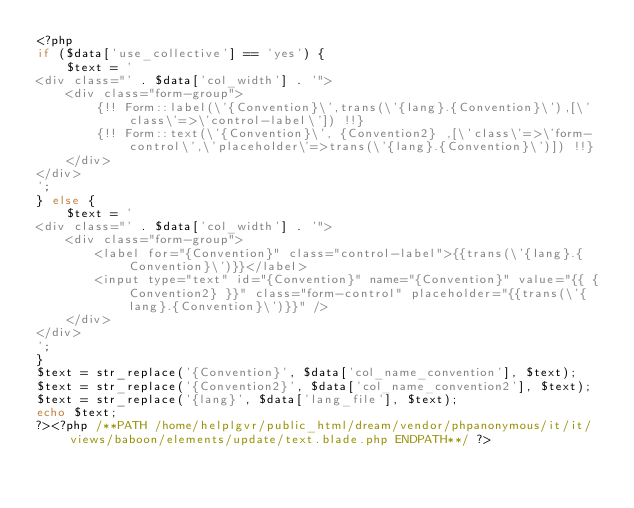<code> <loc_0><loc_0><loc_500><loc_500><_PHP_><?php
if ($data['use_collective'] == 'yes') {
	$text = '
<div class="' . $data['col_width'] . '">
    <div class="form-group">
        {!! Form::label(\'{Convention}\',trans(\'{lang}.{Convention}\'),[\'class\'=>\'control-label\']) !!}
        {!! Form::text(\'{Convention}\', {Convention2} ,[\'class\'=>\'form-control\',\'placeholder\'=>trans(\'{lang}.{Convention}\')]) !!}
    </div>
</div>
';
} else {
	$text = '
<div class="' . $data['col_width'] . '">
    <div class="form-group">
        <label for="{Convention}" class="control-label">{{trans(\'{lang}.{Convention}\')}}</label>
        <input type="text" id="{Convention}" name="{Convention}" value="{{ {Convention2} }}" class="form-control" placeholder="{{trans(\'{lang}.{Convention}\')}}" />
    </div>
</div>
';
}
$text = str_replace('{Convention}', $data['col_name_convention'], $text);
$text = str_replace('{Convention2}', $data['col_name_convention2'], $text);
$text = str_replace('{lang}', $data['lang_file'], $text);
echo $text;
?><?php /**PATH /home/helplgvr/public_html/dream/vendor/phpanonymous/it/it/views/baboon/elements/update/text.blade.php ENDPATH**/ ?></code> 